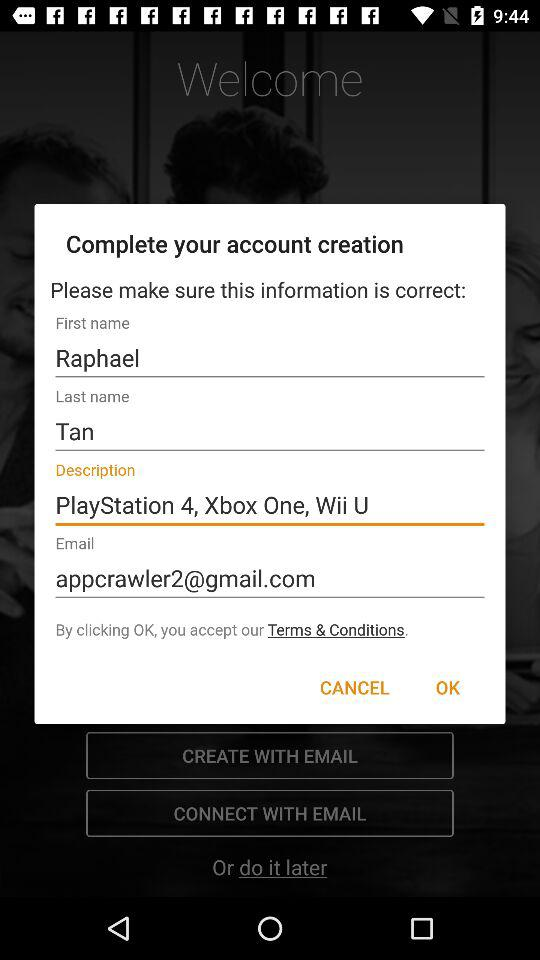What is the first name? The first name is Raphael. 